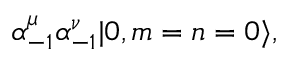Convert formula to latex. <formula><loc_0><loc_0><loc_500><loc_500>\alpha _ { - 1 } ^ { \mu } \alpha _ { - 1 } ^ { \nu } | 0 , m = n = 0 \rangle ,</formula> 